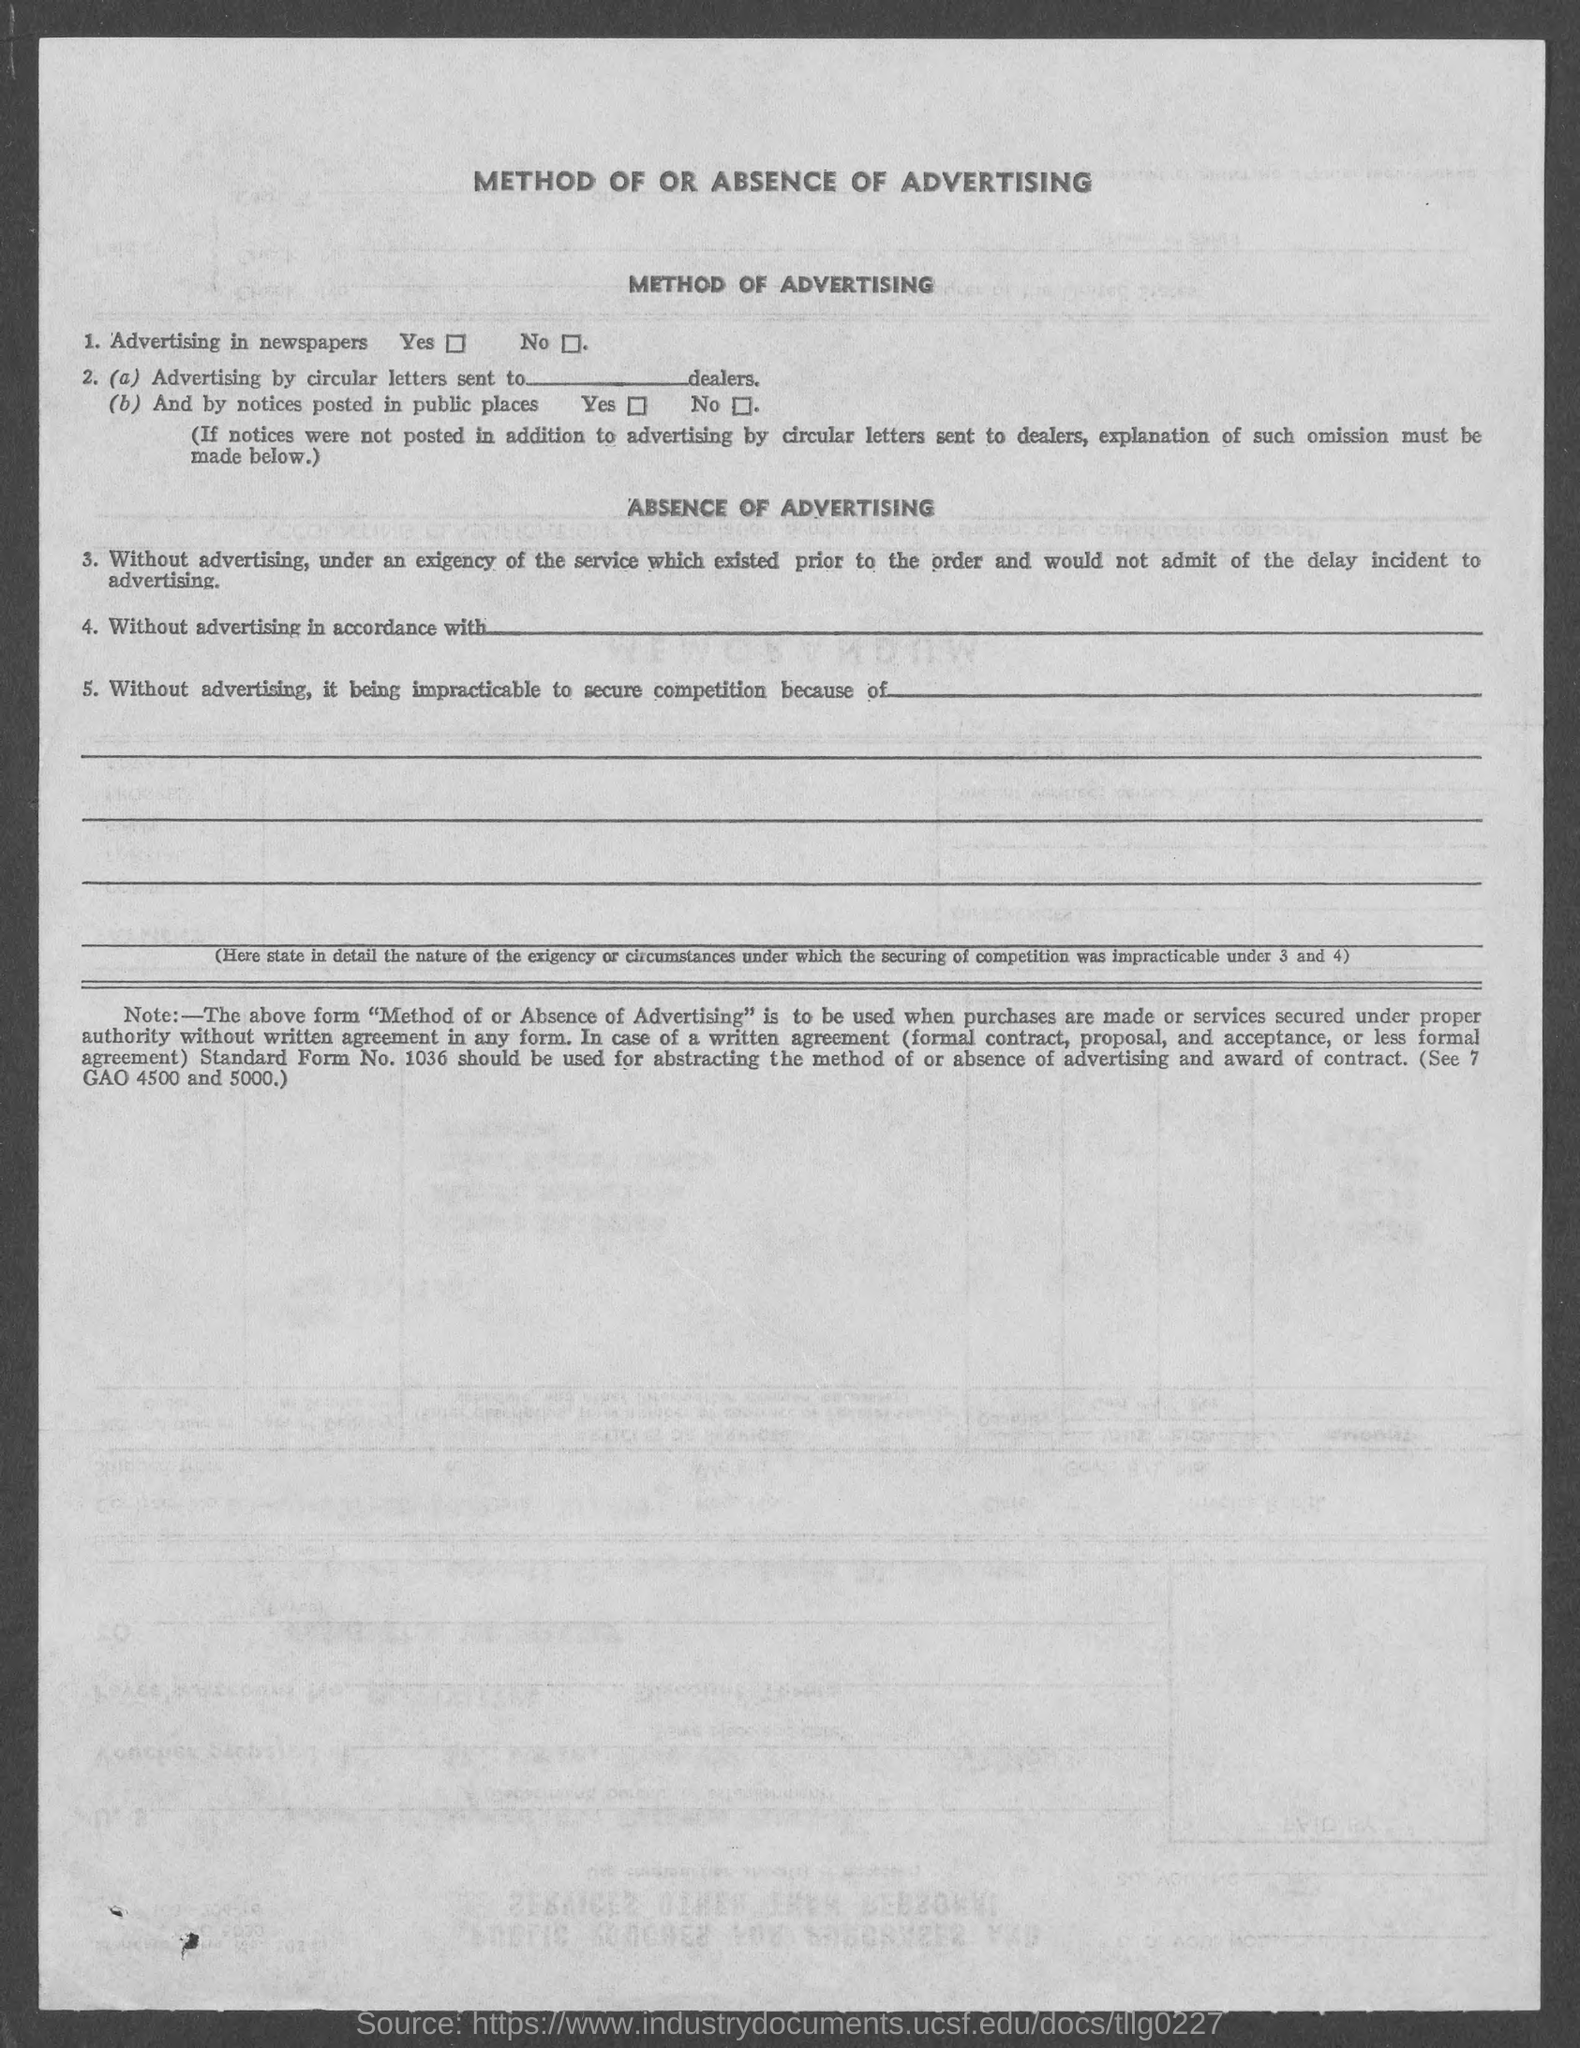Give some essential details in this illustration. The heading at the top of the page is inquiring about the method of advertising or the absence of it. 